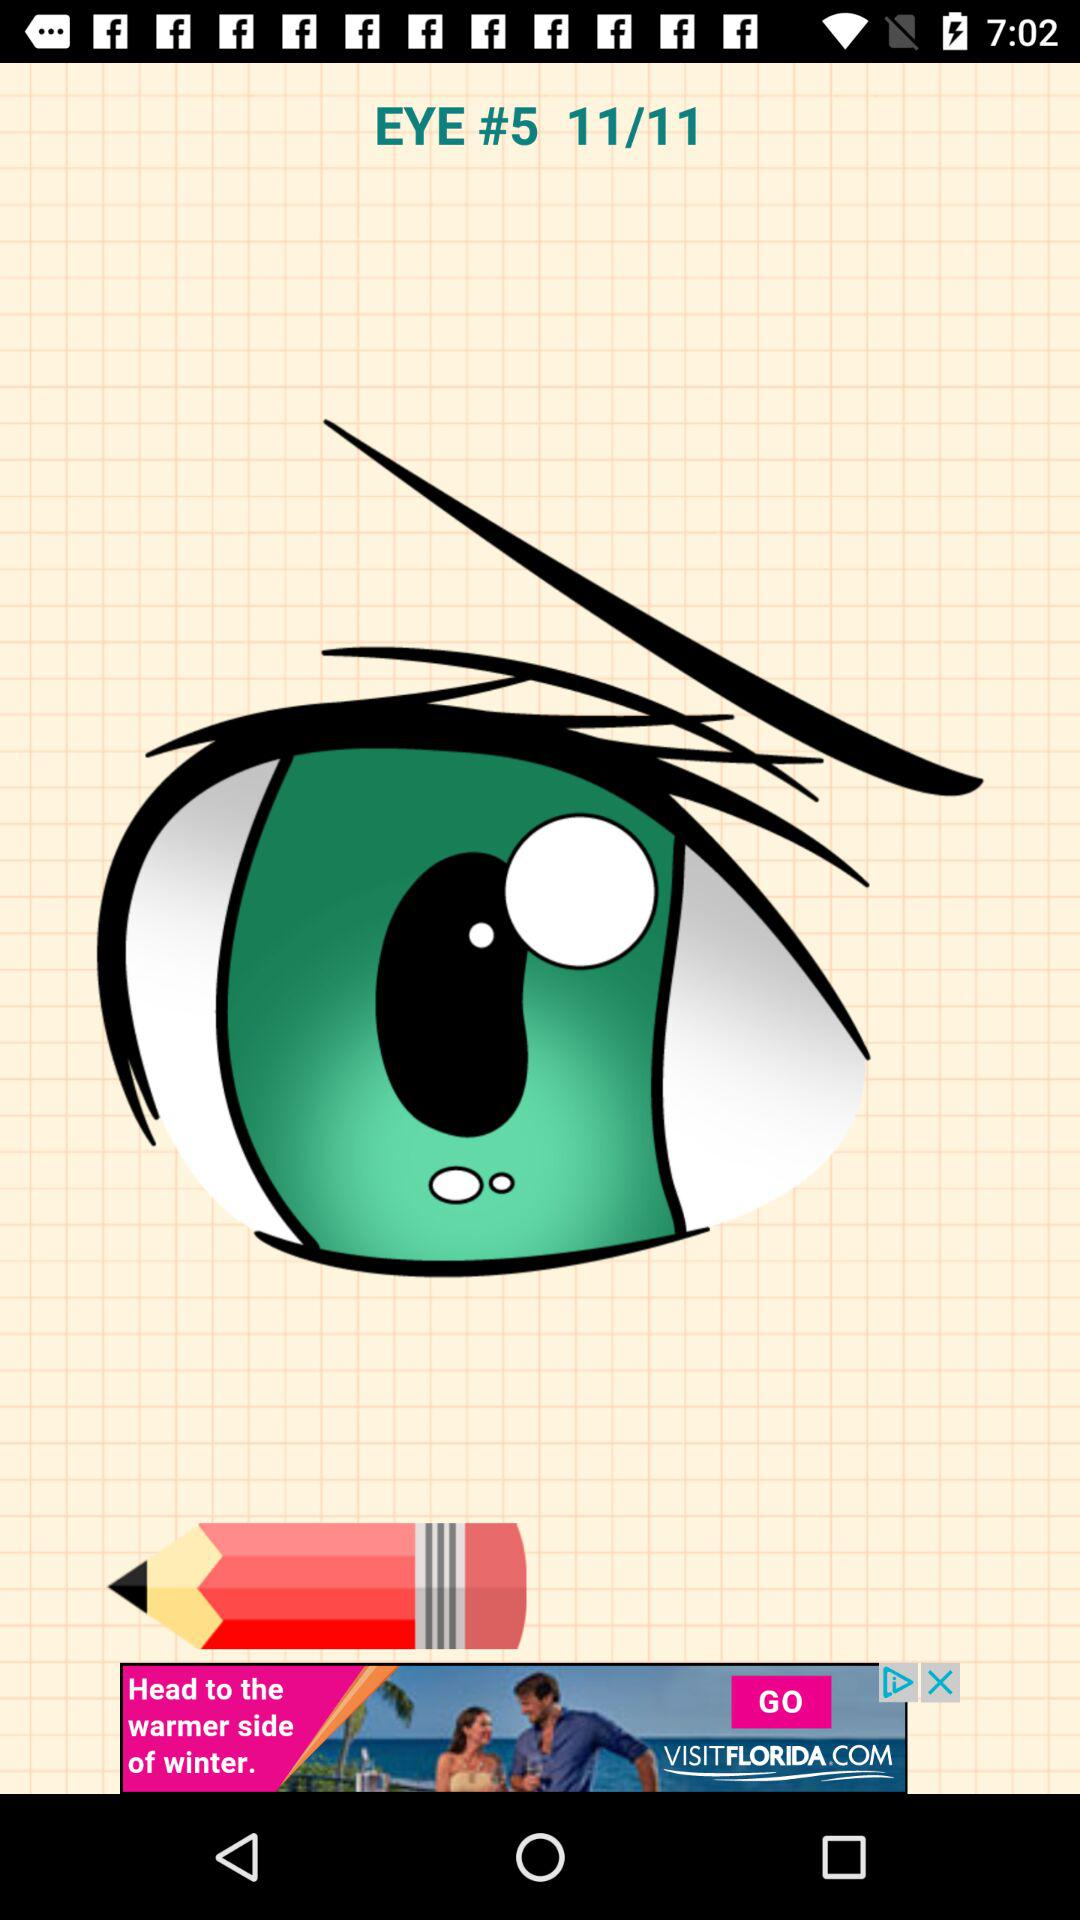On which image is currently the person? The person is currently on image 11. 